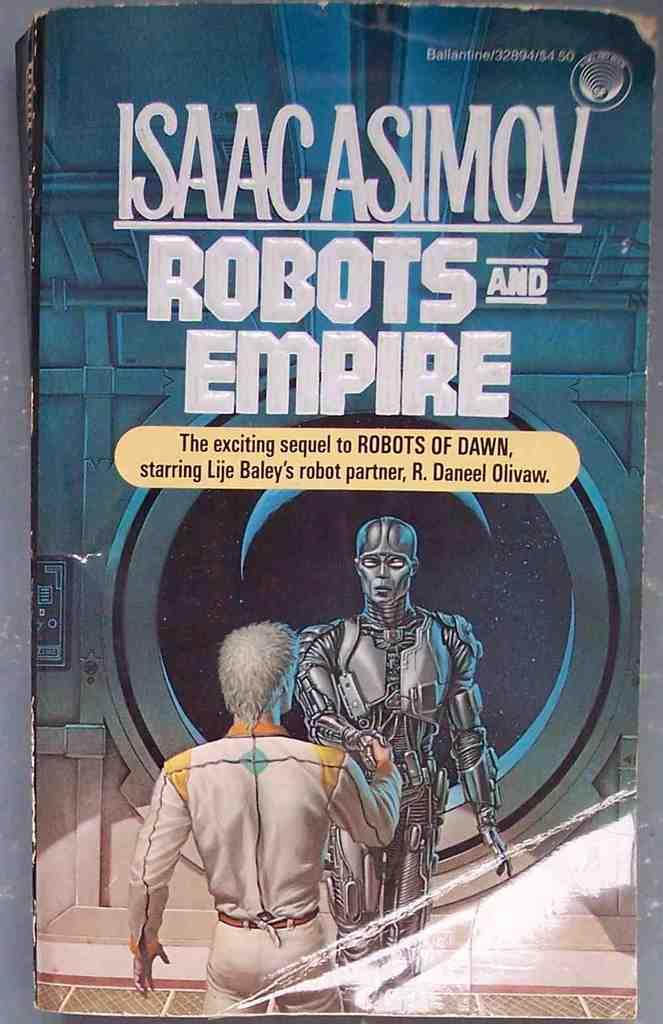<image>
Relay a brief, clear account of the picture shown. An Isaac Asimov book cover includes a robot shaking a man's hand. 